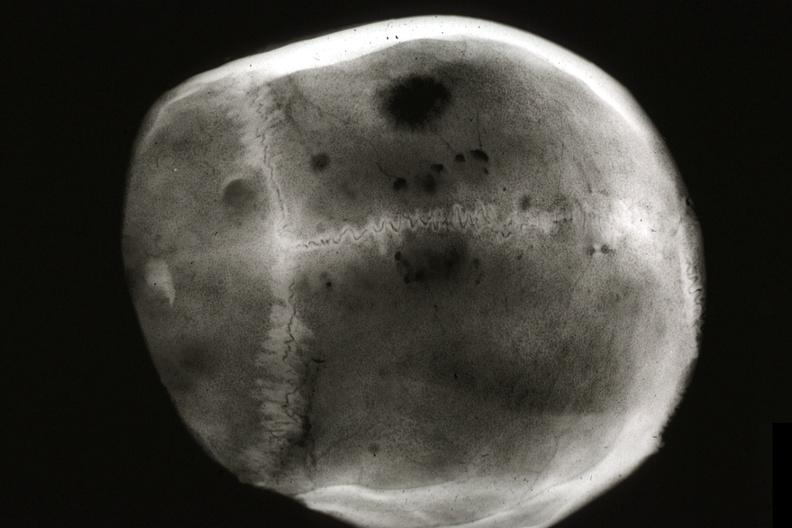s bone, skull present?
Answer the question using a single word or phrase. Yes 